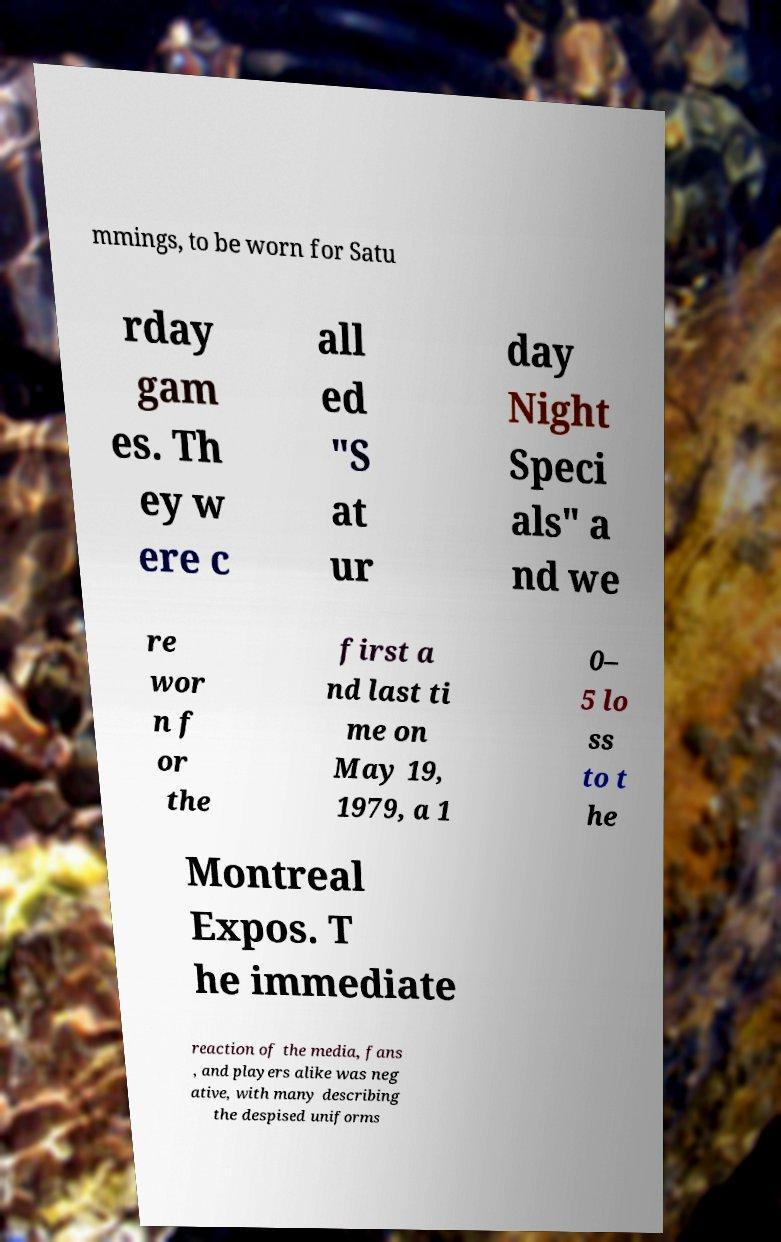What messages or text are displayed in this image? I need them in a readable, typed format. mmings, to be worn for Satu rday gam es. Th ey w ere c all ed "S at ur day Night Speci als" a nd we re wor n f or the first a nd last ti me on May 19, 1979, a 1 0– 5 lo ss to t he Montreal Expos. T he immediate reaction of the media, fans , and players alike was neg ative, with many describing the despised uniforms 